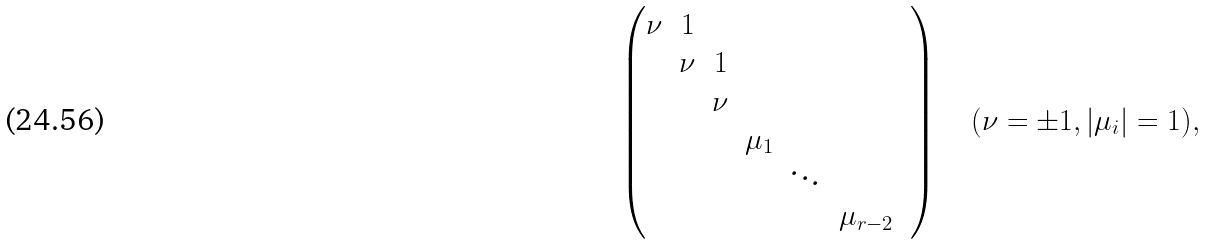<formula> <loc_0><loc_0><loc_500><loc_500>\left ( \begin{matrix} \nu & 1 & & & & & \\ & \nu & 1 & & & & \\ & & \nu & & & & \\ & & & \mu _ { 1 } & & \\ & & & & \ddots & \\ & & & & & \mu _ { r - 2 } \end{matrix} \right ) \quad ( \nu = \pm 1 , | \mu _ { i } | = 1 ) ,</formula> 